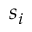<formula> <loc_0><loc_0><loc_500><loc_500>s _ { i }</formula> 